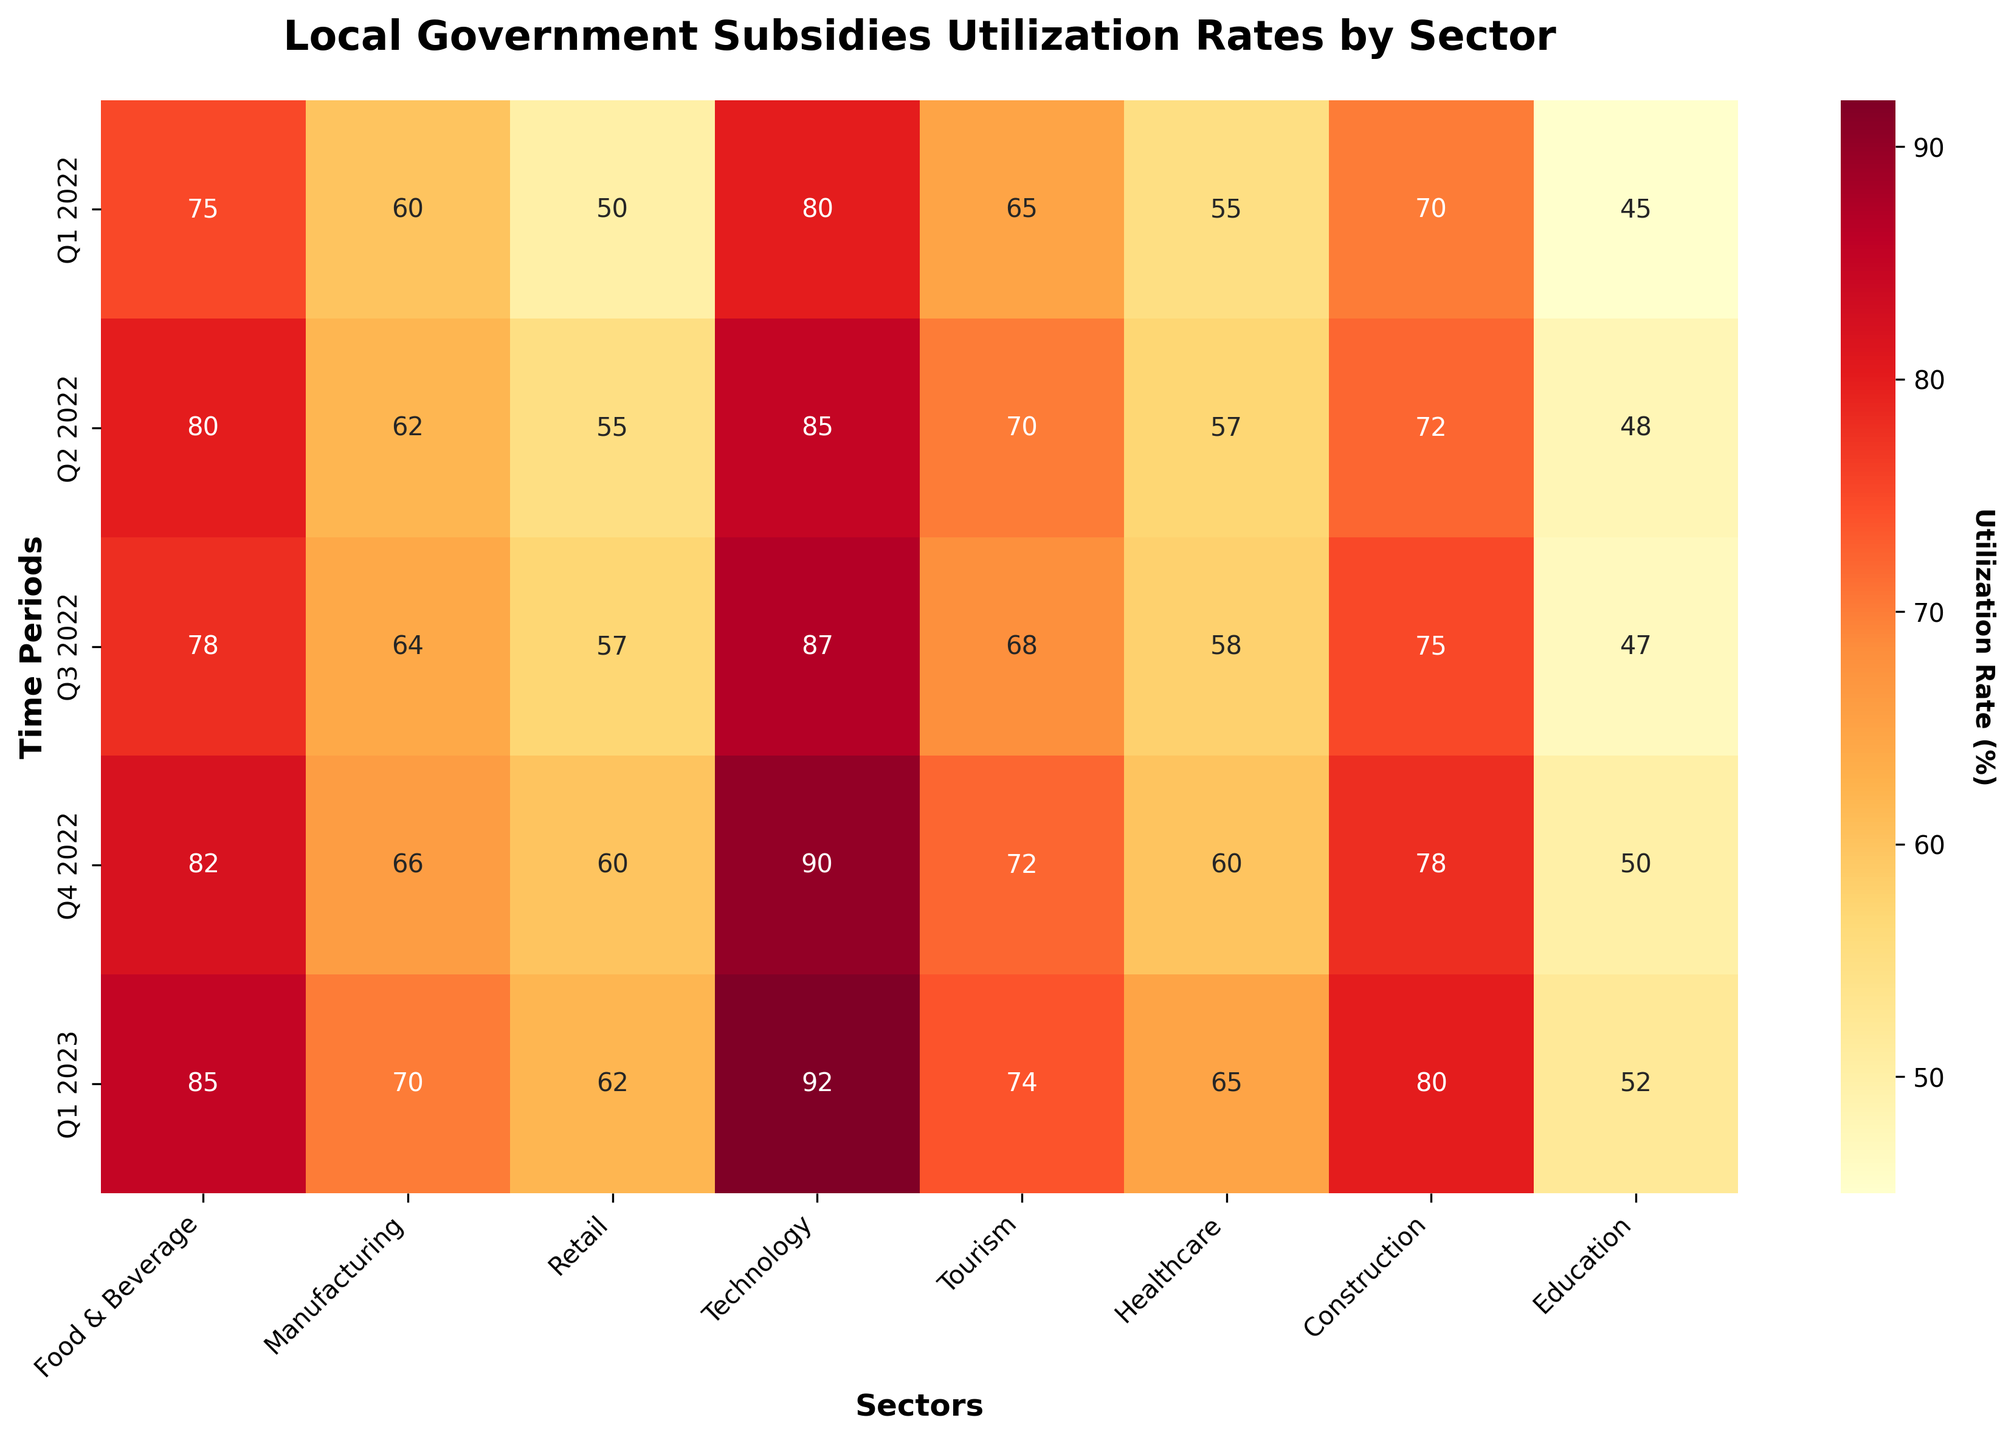What is the highest utilization rate for the Technology sector? To find the highest utilization rate for the Technology sector, locate the 'Technology' column and identify the maximum value. The values are 80, 85, 87, 90, and 92. The highest value is 92, which was in Q1 2023.
Answer: 92% Which period had the lowest utilization rate for the Healthcare sector? To determine the period with the lowest utilization rate for the Healthcare sector, locate the 'Healthcare' column. The values are 55, 57, 58, 60, and 65. The lowest rate is 55, which was in Q1 2022.
Answer: Q1 2022 How did the utilization rate in the Retail sector change from Q1 2022 to Q4 2022? Locate the 'Retail' column and compare the values for Q1 2022 (50) to Q4 2022 (60). There is an increase from 50 to 60. The change is calculated as 60 - 50 = 10.
Answer: Increased by 10 For which sector did the utilization rate increase the most from Q1 2022 to Q1 2023? Check the difference in utilization rates between Q1 2022 and Q1 2023 for all sectors: Food & Beverage (85-75=10), Manufacturing (70-60=10), Retail (62-50=12), Technology (92-80=12), Tourism (74-65=9), Healthcare (65-55=10), Construction (80-70=10), Education (52-45=7). The greatest increase occurred in both the Retail and Technology sectors, each increasing by 12.
Answer: Retail and Technology What is the average utilization rate for the Food & Beverage sector across all periods? Sum the values in the 'Food & Beverage' column (75, 80, 78, 82, 85) and find their average. The sum is 75 + 80 + 78 + 82 + 85 = 400. There are 5 periods, so the average is 400 / 5 = 80.
Answer: 80 Which sector showed the most consistent utilization rate over the periods? The most consistent utilization rate can be seen by examining which column has the smallest fluctuations. The values in the Education sector (45, 48, 47, 50, 52) vary between 45 and 52, showing the smallest range of only 7.
Answer: Education In which quarter was the overall utilization rate for all sectors combined the highest? Compute the sum for each period: Q1 2022 (75+60+50+80+65+55+70+45=500), Q2 2022 (80+62+55+85+70+57+72+48=529), Q3 2022 (78+64+57+87+68+58+75+47=534), Q4 2022 (82+66+60+90+72+60+78+50=558), Q1 2023 (85+70+62+92+74+65+80+52=580). The highest sum is 580 in Q1 2023.
Answer: Q1 2023 